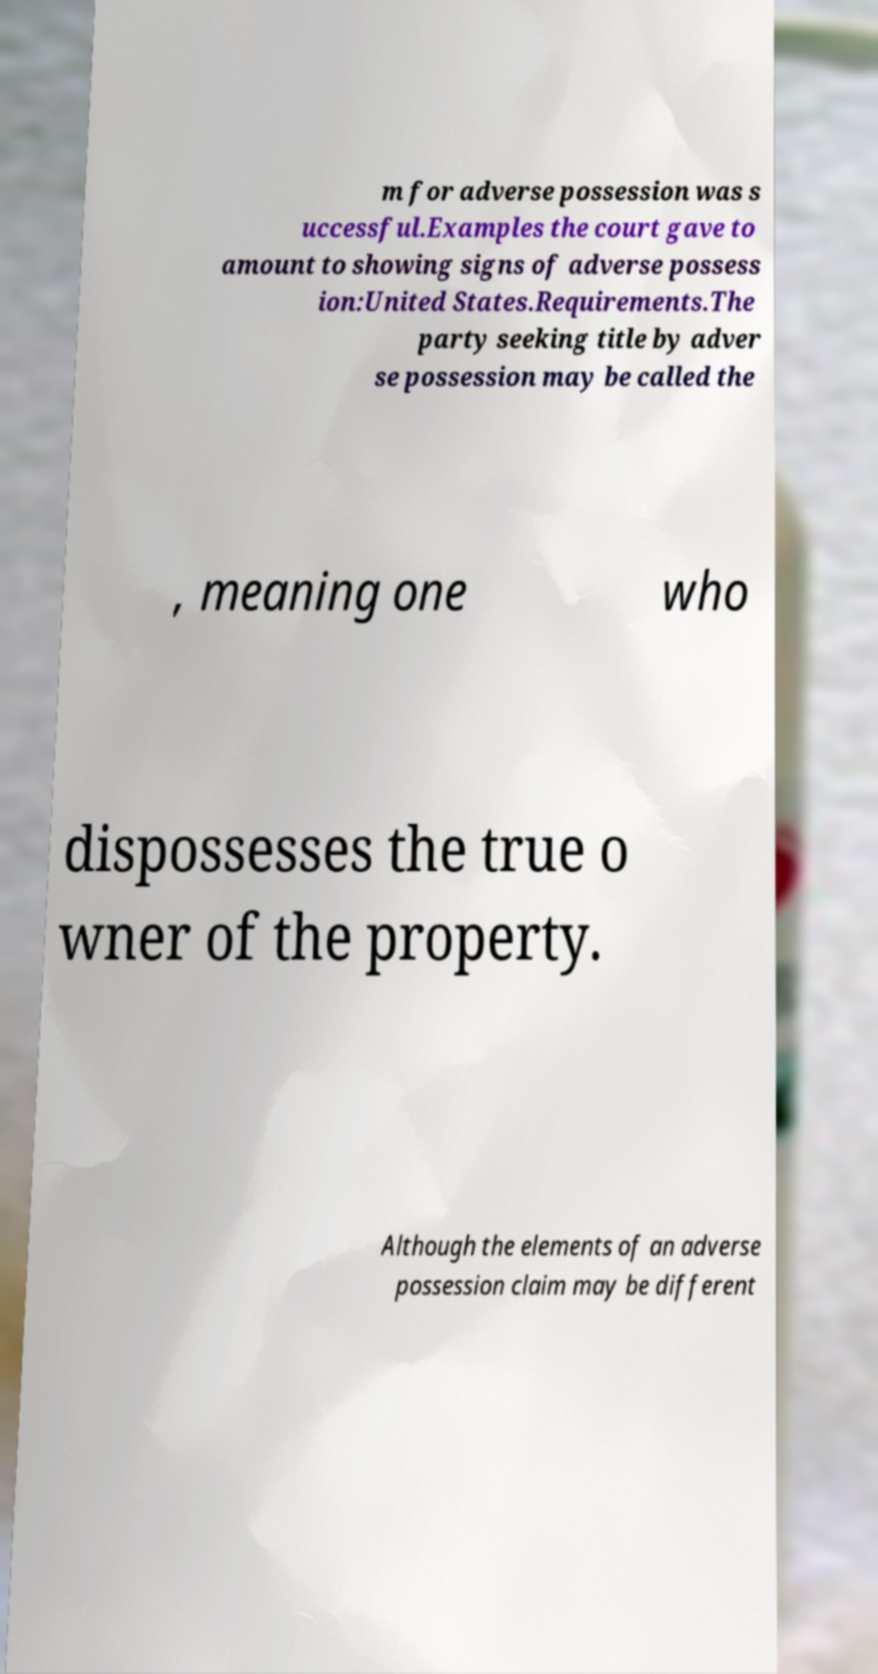For documentation purposes, I need the text within this image transcribed. Could you provide that? m for adverse possession was s uccessful.Examples the court gave to amount to showing signs of adverse possess ion:United States.Requirements.The party seeking title by adver se possession may be called the , meaning one who dispossesses the true o wner of the property. Although the elements of an adverse possession claim may be different 